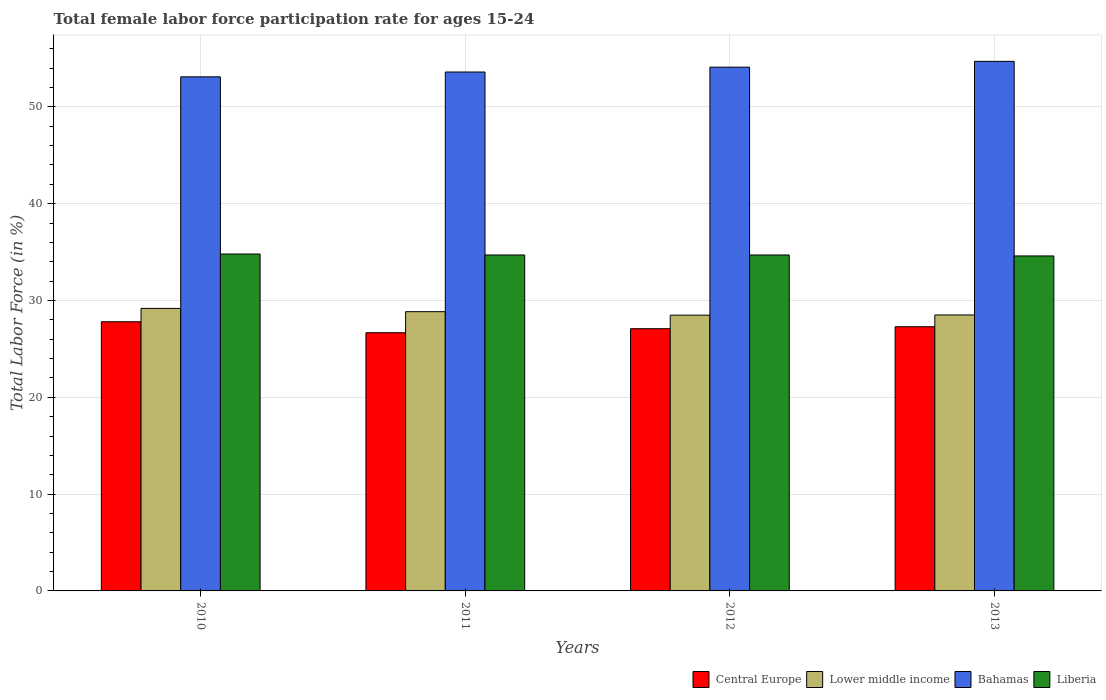How many different coloured bars are there?
Provide a short and direct response. 4. Are the number of bars on each tick of the X-axis equal?
Give a very brief answer. Yes. In how many cases, is the number of bars for a given year not equal to the number of legend labels?
Give a very brief answer. 0. What is the female labor force participation rate in Bahamas in 2010?
Offer a very short reply. 53.1. Across all years, what is the maximum female labor force participation rate in Liberia?
Your answer should be compact. 34.8. Across all years, what is the minimum female labor force participation rate in Bahamas?
Your answer should be very brief. 53.1. In which year was the female labor force participation rate in Liberia minimum?
Ensure brevity in your answer.  2013. What is the total female labor force participation rate in Bahamas in the graph?
Provide a succinct answer. 215.5. What is the difference between the female labor force participation rate in Liberia in 2010 and that in 2013?
Ensure brevity in your answer.  0.2. What is the difference between the female labor force participation rate in Liberia in 2010 and the female labor force participation rate in Lower middle income in 2012?
Ensure brevity in your answer.  6.31. What is the average female labor force participation rate in Liberia per year?
Your response must be concise. 34.7. In the year 2010, what is the difference between the female labor force participation rate in Bahamas and female labor force participation rate in Liberia?
Give a very brief answer. 18.3. What is the ratio of the female labor force participation rate in Central Europe in 2010 to that in 2013?
Offer a very short reply. 1.02. What is the difference between the highest and the second highest female labor force participation rate in Lower middle income?
Offer a very short reply. 0.34. What is the difference between the highest and the lowest female labor force participation rate in Bahamas?
Make the answer very short. 1.6. Is the sum of the female labor force participation rate in Central Europe in 2011 and 2013 greater than the maximum female labor force participation rate in Lower middle income across all years?
Your answer should be very brief. Yes. What does the 2nd bar from the left in 2013 represents?
Offer a terse response. Lower middle income. What does the 2nd bar from the right in 2013 represents?
Provide a succinct answer. Bahamas. Are all the bars in the graph horizontal?
Your response must be concise. No. Are the values on the major ticks of Y-axis written in scientific E-notation?
Your answer should be very brief. No. Does the graph contain any zero values?
Ensure brevity in your answer.  No. Does the graph contain grids?
Make the answer very short. Yes. Where does the legend appear in the graph?
Keep it short and to the point. Bottom right. How are the legend labels stacked?
Your answer should be compact. Horizontal. What is the title of the graph?
Provide a succinct answer. Total female labor force participation rate for ages 15-24. What is the label or title of the X-axis?
Make the answer very short. Years. What is the Total Labor Force (in %) in Central Europe in 2010?
Offer a very short reply. 27.8. What is the Total Labor Force (in %) in Lower middle income in 2010?
Your answer should be very brief. 29.18. What is the Total Labor Force (in %) of Bahamas in 2010?
Your response must be concise. 53.1. What is the Total Labor Force (in %) of Liberia in 2010?
Offer a terse response. 34.8. What is the Total Labor Force (in %) of Central Europe in 2011?
Your answer should be very brief. 26.67. What is the Total Labor Force (in %) in Lower middle income in 2011?
Provide a short and direct response. 28.85. What is the Total Labor Force (in %) in Bahamas in 2011?
Ensure brevity in your answer.  53.6. What is the Total Labor Force (in %) of Liberia in 2011?
Ensure brevity in your answer.  34.7. What is the Total Labor Force (in %) of Central Europe in 2012?
Offer a very short reply. 27.09. What is the Total Labor Force (in %) in Lower middle income in 2012?
Make the answer very short. 28.49. What is the Total Labor Force (in %) in Bahamas in 2012?
Ensure brevity in your answer.  54.1. What is the Total Labor Force (in %) of Liberia in 2012?
Your answer should be very brief. 34.7. What is the Total Labor Force (in %) in Central Europe in 2013?
Offer a very short reply. 27.29. What is the Total Labor Force (in %) of Lower middle income in 2013?
Make the answer very short. 28.5. What is the Total Labor Force (in %) of Bahamas in 2013?
Give a very brief answer. 54.7. What is the Total Labor Force (in %) of Liberia in 2013?
Provide a succinct answer. 34.6. Across all years, what is the maximum Total Labor Force (in %) in Central Europe?
Your response must be concise. 27.8. Across all years, what is the maximum Total Labor Force (in %) of Lower middle income?
Your answer should be very brief. 29.18. Across all years, what is the maximum Total Labor Force (in %) in Bahamas?
Give a very brief answer. 54.7. Across all years, what is the maximum Total Labor Force (in %) of Liberia?
Offer a very short reply. 34.8. Across all years, what is the minimum Total Labor Force (in %) in Central Europe?
Your answer should be very brief. 26.67. Across all years, what is the minimum Total Labor Force (in %) in Lower middle income?
Make the answer very short. 28.49. Across all years, what is the minimum Total Labor Force (in %) in Bahamas?
Offer a very short reply. 53.1. Across all years, what is the minimum Total Labor Force (in %) of Liberia?
Provide a succinct answer. 34.6. What is the total Total Labor Force (in %) of Central Europe in the graph?
Your answer should be compact. 108.85. What is the total Total Labor Force (in %) in Lower middle income in the graph?
Ensure brevity in your answer.  115.02. What is the total Total Labor Force (in %) of Bahamas in the graph?
Keep it short and to the point. 215.5. What is the total Total Labor Force (in %) in Liberia in the graph?
Keep it short and to the point. 138.8. What is the difference between the Total Labor Force (in %) in Central Europe in 2010 and that in 2011?
Keep it short and to the point. 1.13. What is the difference between the Total Labor Force (in %) of Lower middle income in 2010 and that in 2011?
Keep it short and to the point. 0.34. What is the difference between the Total Labor Force (in %) in Central Europe in 2010 and that in 2012?
Offer a very short reply. 0.72. What is the difference between the Total Labor Force (in %) of Lower middle income in 2010 and that in 2012?
Provide a succinct answer. 0.7. What is the difference between the Total Labor Force (in %) of Central Europe in 2010 and that in 2013?
Keep it short and to the point. 0.51. What is the difference between the Total Labor Force (in %) of Lower middle income in 2010 and that in 2013?
Ensure brevity in your answer.  0.68. What is the difference between the Total Labor Force (in %) in Liberia in 2010 and that in 2013?
Offer a terse response. 0.2. What is the difference between the Total Labor Force (in %) of Central Europe in 2011 and that in 2012?
Keep it short and to the point. -0.42. What is the difference between the Total Labor Force (in %) in Lower middle income in 2011 and that in 2012?
Offer a terse response. 0.36. What is the difference between the Total Labor Force (in %) of Central Europe in 2011 and that in 2013?
Keep it short and to the point. -0.62. What is the difference between the Total Labor Force (in %) of Lower middle income in 2011 and that in 2013?
Provide a short and direct response. 0.34. What is the difference between the Total Labor Force (in %) in Bahamas in 2011 and that in 2013?
Provide a succinct answer. -1.1. What is the difference between the Total Labor Force (in %) of Liberia in 2011 and that in 2013?
Your response must be concise. 0.1. What is the difference between the Total Labor Force (in %) in Central Europe in 2012 and that in 2013?
Keep it short and to the point. -0.2. What is the difference between the Total Labor Force (in %) in Lower middle income in 2012 and that in 2013?
Your response must be concise. -0.02. What is the difference between the Total Labor Force (in %) in Bahamas in 2012 and that in 2013?
Provide a succinct answer. -0.6. What is the difference between the Total Labor Force (in %) in Central Europe in 2010 and the Total Labor Force (in %) in Lower middle income in 2011?
Your response must be concise. -1.04. What is the difference between the Total Labor Force (in %) in Central Europe in 2010 and the Total Labor Force (in %) in Bahamas in 2011?
Provide a succinct answer. -25.8. What is the difference between the Total Labor Force (in %) of Central Europe in 2010 and the Total Labor Force (in %) of Liberia in 2011?
Your response must be concise. -6.9. What is the difference between the Total Labor Force (in %) of Lower middle income in 2010 and the Total Labor Force (in %) of Bahamas in 2011?
Provide a succinct answer. -24.42. What is the difference between the Total Labor Force (in %) of Lower middle income in 2010 and the Total Labor Force (in %) of Liberia in 2011?
Your answer should be very brief. -5.52. What is the difference between the Total Labor Force (in %) of Bahamas in 2010 and the Total Labor Force (in %) of Liberia in 2011?
Keep it short and to the point. 18.4. What is the difference between the Total Labor Force (in %) of Central Europe in 2010 and the Total Labor Force (in %) of Lower middle income in 2012?
Provide a succinct answer. -0.68. What is the difference between the Total Labor Force (in %) of Central Europe in 2010 and the Total Labor Force (in %) of Bahamas in 2012?
Give a very brief answer. -26.3. What is the difference between the Total Labor Force (in %) in Central Europe in 2010 and the Total Labor Force (in %) in Liberia in 2012?
Ensure brevity in your answer.  -6.9. What is the difference between the Total Labor Force (in %) in Lower middle income in 2010 and the Total Labor Force (in %) in Bahamas in 2012?
Offer a very short reply. -24.92. What is the difference between the Total Labor Force (in %) of Lower middle income in 2010 and the Total Labor Force (in %) of Liberia in 2012?
Provide a short and direct response. -5.52. What is the difference between the Total Labor Force (in %) of Bahamas in 2010 and the Total Labor Force (in %) of Liberia in 2012?
Your response must be concise. 18.4. What is the difference between the Total Labor Force (in %) in Central Europe in 2010 and the Total Labor Force (in %) in Lower middle income in 2013?
Ensure brevity in your answer.  -0.7. What is the difference between the Total Labor Force (in %) in Central Europe in 2010 and the Total Labor Force (in %) in Bahamas in 2013?
Your answer should be compact. -26.9. What is the difference between the Total Labor Force (in %) of Central Europe in 2010 and the Total Labor Force (in %) of Liberia in 2013?
Offer a terse response. -6.8. What is the difference between the Total Labor Force (in %) in Lower middle income in 2010 and the Total Labor Force (in %) in Bahamas in 2013?
Offer a very short reply. -25.52. What is the difference between the Total Labor Force (in %) of Lower middle income in 2010 and the Total Labor Force (in %) of Liberia in 2013?
Your response must be concise. -5.42. What is the difference between the Total Labor Force (in %) of Bahamas in 2010 and the Total Labor Force (in %) of Liberia in 2013?
Provide a succinct answer. 18.5. What is the difference between the Total Labor Force (in %) in Central Europe in 2011 and the Total Labor Force (in %) in Lower middle income in 2012?
Your response must be concise. -1.82. What is the difference between the Total Labor Force (in %) of Central Europe in 2011 and the Total Labor Force (in %) of Bahamas in 2012?
Your answer should be very brief. -27.43. What is the difference between the Total Labor Force (in %) in Central Europe in 2011 and the Total Labor Force (in %) in Liberia in 2012?
Keep it short and to the point. -8.03. What is the difference between the Total Labor Force (in %) in Lower middle income in 2011 and the Total Labor Force (in %) in Bahamas in 2012?
Provide a short and direct response. -25.25. What is the difference between the Total Labor Force (in %) of Lower middle income in 2011 and the Total Labor Force (in %) of Liberia in 2012?
Offer a very short reply. -5.85. What is the difference between the Total Labor Force (in %) of Central Europe in 2011 and the Total Labor Force (in %) of Lower middle income in 2013?
Make the answer very short. -1.83. What is the difference between the Total Labor Force (in %) of Central Europe in 2011 and the Total Labor Force (in %) of Bahamas in 2013?
Offer a very short reply. -28.03. What is the difference between the Total Labor Force (in %) in Central Europe in 2011 and the Total Labor Force (in %) in Liberia in 2013?
Your answer should be very brief. -7.93. What is the difference between the Total Labor Force (in %) in Lower middle income in 2011 and the Total Labor Force (in %) in Bahamas in 2013?
Your answer should be very brief. -25.85. What is the difference between the Total Labor Force (in %) of Lower middle income in 2011 and the Total Labor Force (in %) of Liberia in 2013?
Make the answer very short. -5.75. What is the difference between the Total Labor Force (in %) in Bahamas in 2011 and the Total Labor Force (in %) in Liberia in 2013?
Offer a very short reply. 19. What is the difference between the Total Labor Force (in %) of Central Europe in 2012 and the Total Labor Force (in %) of Lower middle income in 2013?
Keep it short and to the point. -1.42. What is the difference between the Total Labor Force (in %) in Central Europe in 2012 and the Total Labor Force (in %) in Bahamas in 2013?
Offer a terse response. -27.61. What is the difference between the Total Labor Force (in %) in Central Europe in 2012 and the Total Labor Force (in %) in Liberia in 2013?
Offer a very short reply. -7.51. What is the difference between the Total Labor Force (in %) in Lower middle income in 2012 and the Total Labor Force (in %) in Bahamas in 2013?
Your response must be concise. -26.21. What is the difference between the Total Labor Force (in %) in Lower middle income in 2012 and the Total Labor Force (in %) in Liberia in 2013?
Ensure brevity in your answer.  -6.11. What is the difference between the Total Labor Force (in %) of Bahamas in 2012 and the Total Labor Force (in %) of Liberia in 2013?
Keep it short and to the point. 19.5. What is the average Total Labor Force (in %) of Central Europe per year?
Provide a succinct answer. 27.21. What is the average Total Labor Force (in %) in Lower middle income per year?
Your answer should be compact. 28.75. What is the average Total Labor Force (in %) in Bahamas per year?
Keep it short and to the point. 53.88. What is the average Total Labor Force (in %) in Liberia per year?
Offer a very short reply. 34.7. In the year 2010, what is the difference between the Total Labor Force (in %) of Central Europe and Total Labor Force (in %) of Lower middle income?
Offer a terse response. -1.38. In the year 2010, what is the difference between the Total Labor Force (in %) of Central Europe and Total Labor Force (in %) of Bahamas?
Your answer should be compact. -25.3. In the year 2010, what is the difference between the Total Labor Force (in %) of Central Europe and Total Labor Force (in %) of Liberia?
Give a very brief answer. -7. In the year 2010, what is the difference between the Total Labor Force (in %) in Lower middle income and Total Labor Force (in %) in Bahamas?
Give a very brief answer. -23.92. In the year 2010, what is the difference between the Total Labor Force (in %) in Lower middle income and Total Labor Force (in %) in Liberia?
Keep it short and to the point. -5.62. In the year 2011, what is the difference between the Total Labor Force (in %) in Central Europe and Total Labor Force (in %) in Lower middle income?
Offer a very short reply. -2.18. In the year 2011, what is the difference between the Total Labor Force (in %) of Central Europe and Total Labor Force (in %) of Bahamas?
Provide a short and direct response. -26.93. In the year 2011, what is the difference between the Total Labor Force (in %) in Central Europe and Total Labor Force (in %) in Liberia?
Your response must be concise. -8.03. In the year 2011, what is the difference between the Total Labor Force (in %) of Lower middle income and Total Labor Force (in %) of Bahamas?
Offer a very short reply. -24.75. In the year 2011, what is the difference between the Total Labor Force (in %) of Lower middle income and Total Labor Force (in %) of Liberia?
Ensure brevity in your answer.  -5.85. In the year 2011, what is the difference between the Total Labor Force (in %) in Bahamas and Total Labor Force (in %) in Liberia?
Make the answer very short. 18.9. In the year 2012, what is the difference between the Total Labor Force (in %) of Central Europe and Total Labor Force (in %) of Lower middle income?
Provide a succinct answer. -1.4. In the year 2012, what is the difference between the Total Labor Force (in %) in Central Europe and Total Labor Force (in %) in Bahamas?
Provide a succinct answer. -27.01. In the year 2012, what is the difference between the Total Labor Force (in %) of Central Europe and Total Labor Force (in %) of Liberia?
Your response must be concise. -7.61. In the year 2012, what is the difference between the Total Labor Force (in %) of Lower middle income and Total Labor Force (in %) of Bahamas?
Provide a succinct answer. -25.61. In the year 2012, what is the difference between the Total Labor Force (in %) of Lower middle income and Total Labor Force (in %) of Liberia?
Offer a very short reply. -6.21. In the year 2013, what is the difference between the Total Labor Force (in %) of Central Europe and Total Labor Force (in %) of Lower middle income?
Offer a very short reply. -1.22. In the year 2013, what is the difference between the Total Labor Force (in %) of Central Europe and Total Labor Force (in %) of Bahamas?
Give a very brief answer. -27.41. In the year 2013, what is the difference between the Total Labor Force (in %) in Central Europe and Total Labor Force (in %) in Liberia?
Keep it short and to the point. -7.31. In the year 2013, what is the difference between the Total Labor Force (in %) of Lower middle income and Total Labor Force (in %) of Bahamas?
Your response must be concise. -26.2. In the year 2013, what is the difference between the Total Labor Force (in %) in Lower middle income and Total Labor Force (in %) in Liberia?
Your response must be concise. -6.1. In the year 2013, what is the difference between the Total Labor Force (in %) in Bahamas and Total Labor Force (in %) in Liberia?
Provide a short and direct response. 20.1. What is the ratio of the Total Labor Force (in %) in Central Europe in 2010 to that in 2011?
Your answer should be very brief. 1.04. What is the ratio of the Total Labor Force (in %) in Lower middle income in 2010 to that in 2011?
Provide a short and direct response. 1.01. What is the ratio of the Total Labor Force (in %) in Central Europe in 2010 to that in 2012?
Give a very brief answer. 1.03. What is the ratio of the Total Labor Force (in %) of Lower middle income in 2010 to that in 2012?
Keep it short and to the point. 1.02. What is the ratio of the Total Labor Force (in %) of Bahamas in 2010 to that in 2012?
Provide a short and direct response. 0.98. What is the ratio of the Total Labor Force (in %) in Liberia in 2010 to that in 2012?
Give a very brief answer. 1. What is the ratio of the Total Labor Force (in %) in Central Europe in 2010 to that in 2013?
Keep it short and to the point. 1.02. What is the ratio of the Total Labor Force (in %) of Lower middle income in 2010 to that in 2013?
Offer a very short reply. 1.02. What is the ratio of the Total Labor Force (in %) of Bahamas in 2010 to that in 2013?
Provide a succinct answer. 0.97. What is the ratio of the Total Labor Force (in %) in Central Europe in 2011 to that in 2012?
Your answer should be very brief. 0.98. What is the ratio of the Total Labor Force (in %) of Lower middle income in 2011 to that in 2012?
Your response must be concise. 1.01. What is the ratio of the Total Labor Force (in %) of Bahamas in 2011 to that in 2012?
Provide a succinct answer. 0.99. What is the ratio of the Total Labor Force (in %) of Central Europe in 2011 to that in 2013?
Your answer should be very brief. 0.98. What is the ratio of the Total Labor Force (in %) of Bahamas in 2011 to that in 2013?
Keep it short and to the point. 0.98. What is the ratio of the Total Labor Force (in %) in Liberia in 2011 to that in 2013?
Provide a succinct answer. 1. What is the ratio of the Total Labor Force (in %) in Central Europe in 2012 to that in 2013?
Provide a succinct answer. 0.99. What is the ratio of the Total Labor Force (in %) of Lower middle income in 2012 to that in 2013?
Give a very brief answer. 1. What is the ratio of the Total Labor Force (in %) of Liberia in 2012 to that in 2013?
Give a very brief answer. 1. What is the difference between the highest and the second highest Total Labor Force (in %) of Central Europe?
Provide a short and direct response. 0.51. What is the difference between the highest and the second highest Total Labor Force (in %) of Lower middle income?
Provide a short and direct response. 0.34. What is the difference between the highest and the second highest Total Labor Force (in %) in Bahamas?
Your response must be concise. 0.6. What is the difference between the highest and the second highest Total Labor Force (in %) of Liberia?
Your answer should be very brief. 0.1. What is the difference between the highest and the lowest Total Labor Force (in %) of Central Europe?
Provide a short and direct response. 1.13. What is the difference between the highest and the lowest Total Labor Force (in %) in Lower middle income?
Offer a terse response. 0.7. What is the difference between the highest and the lowest Total Labor Force (in %) of Liberia?
Your response must be concise. 0.2. 